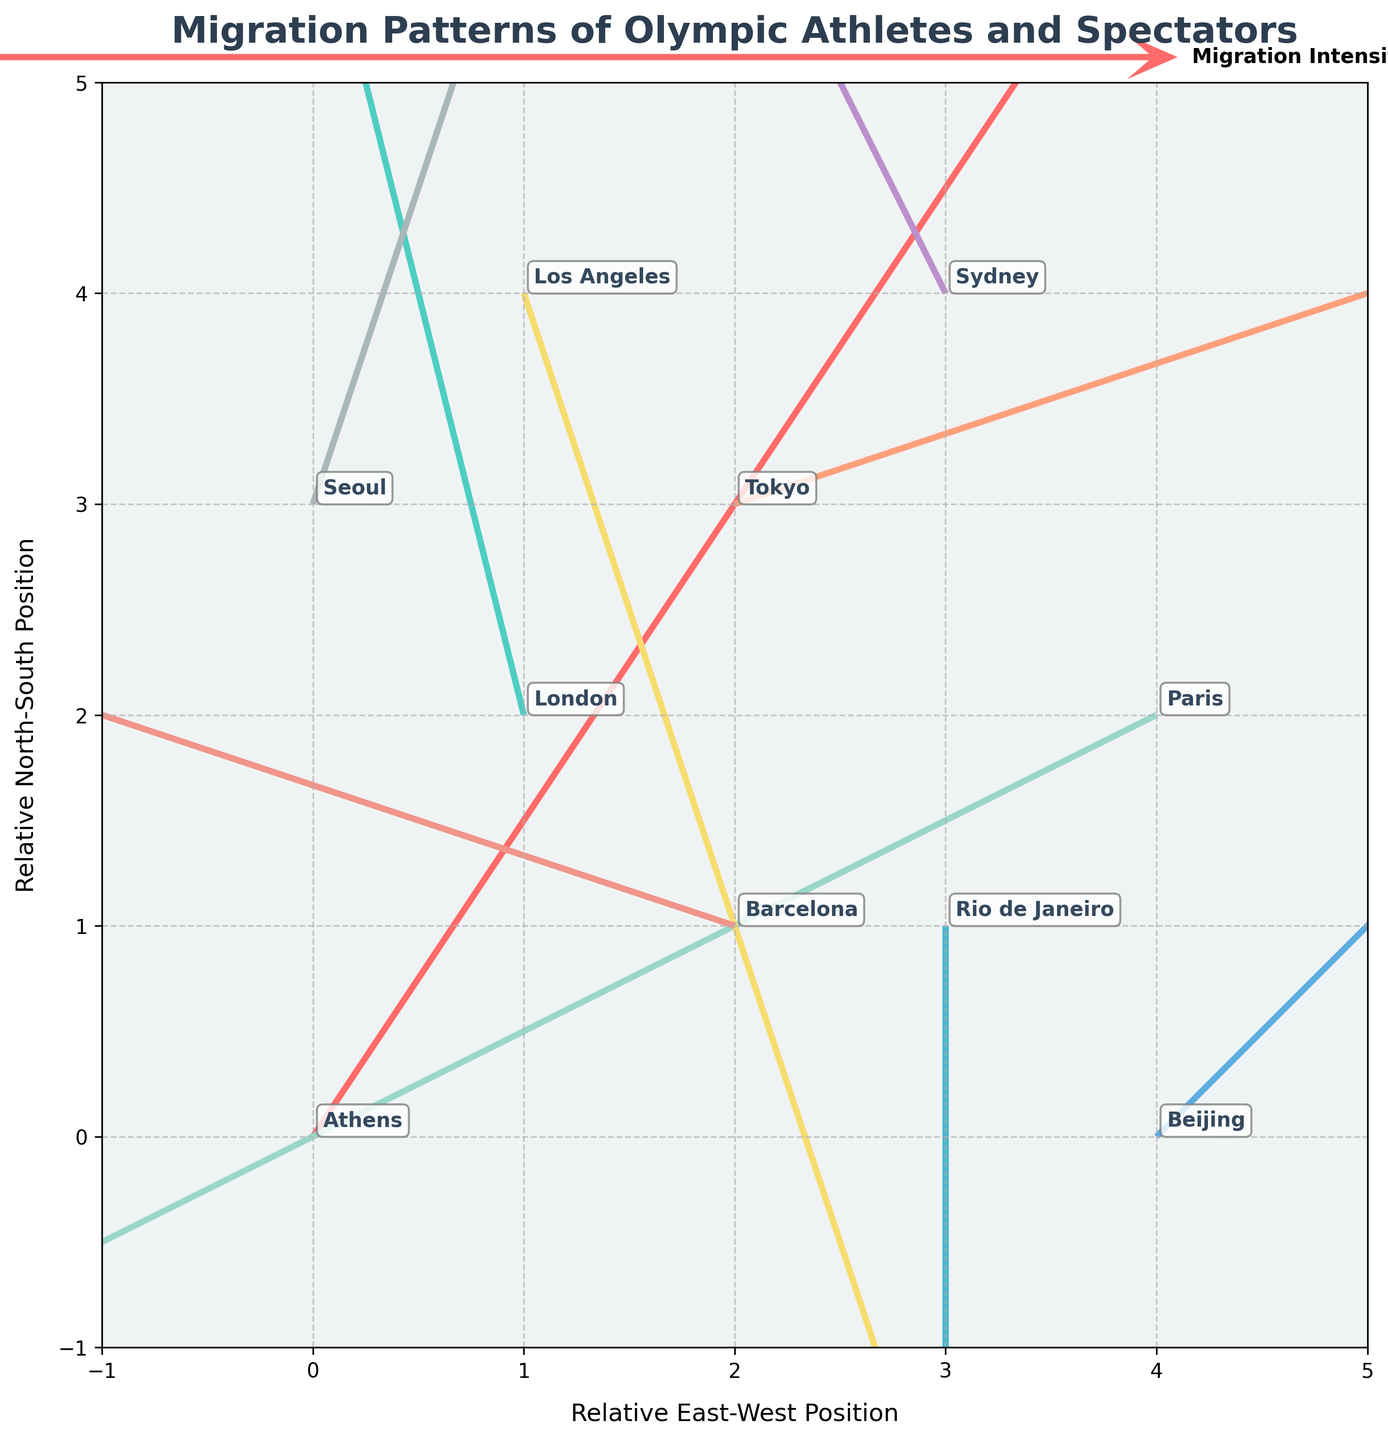what is the visual title of the plot? The title is displayed at the top of the plot. By reading the text, we can determine the title of the plot.
Answer: Migration Patterns of Olympic Athletes and Spectators What are the labels of the axes on the plot? By looking at the text along the horizontal and vertical lines (axes), we can read the labels provided. The x-axis is labeled "Relative East-West Position" and the y-axis is labeled "Relative North-South Position."
Answer: Relative East-West Position and Relative North-South Position How many cities are indicated on the plot? By counting the number of unique texts or labels on the plot representing city names, we can determine the number of cities.
Answer: 10 Which city has the longest migration vector? By identifying the city label with the vector (arrow) that extends the farthest from its origin (the city's location point), we can see that the vector migration for London is visually represented as the longest.
Answer: London Which direction is the migration from Sydney primarily moving towards? Analyzing the direction of the arrow originating from Sydney, we can observe if it points left, right, upwards, or downwards. The vector from Sydney points upwards.
Answer: Upwards Compare the migration intensity between Beijing and Barcelona. Which one has a higher migration intensity? The magnitude (length) of the arrows indicates migration intensity. By comparing the lengths of the arrows from Beijing and Barcelona, it is evident that Beijing's migration vector is longer.
Answer: Beijing Which cities show a downward migration pattern? By examining the direction of the arrows for each city, we identify which arrows point downward. Both Rio de Janeiro and Los Angeles display a downward migration vector.
Answer: Rio de Janeiro and Los Angeles Is there any city from which the migration vector does not change along the x-axis? Vector migration without horizontal change (x=0) means that the vector only moves in the y-direction. Observing the vector's components for Rio de Janeiro shows that it has zero movement in the x-axis direction.
Answer: Rio de Janeiro What is the average migration intensity of the vectors originating from Seoul and Beijing? By calculating the magnitudes of the vectors and averaging the result, we can find the average migration intensity. Seoul has a vector magnitude calculated as √(1^2 + 3^2) = √10 ≈ 3.16, and Beijing has √(2^2 + 2^2) = √8 ≈ 2.83. The average is (3.16 + 2.83) / 2 ≈ 2.99.
Answer: 2.99 What is the total vector movement from Athens in both the x and y directions? Summing the vector components u and v for Athens indicates the total movement. Athens has u = 2 and v = 3, so the total movement in the x-direction is 2 and in the y-direction is 3. The vector movements are not summed as magnitudes but as components.
Answer: 2 in x-direction, 3 in y-direction 